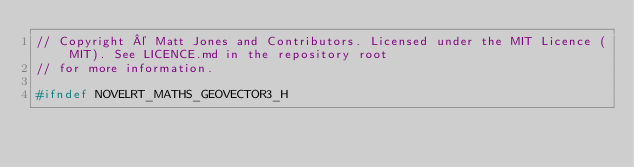Convert code to text. <code><loc_0><loc_0><loc_500><loc_500><_C_>// Copyright © Matt Jones and Contributors. Licensed under the MIT Licence (MIT). See LICENCE.md in the repository root
// for more information.

#ifndef NOVELRT_MATHS_GEOVECTOR3_H</code> 